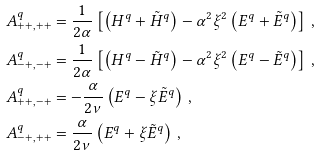<formula> <loc_0><loc_0><loc_500><loc_500>A _ { + + , + + } ^ { q } & = \frac { 1 } { 2 \alpha } \left [ \left ( H ^ { q } + \tilde { H } ^ { q } \right ) - \alpha ^ { 2 } \xi ^ { 2 } \left ( E ^ { q } + \tilde { E } ^ { q } \right ) \right ] \, , \\ A _ { - + , - + } ^ { q } & = \frac { 1 } { 2 \alpha } \left [ \left ( H ^ { q } - \tilde { H } ^ { q } \right ) - \alpha ^ { 2 } \xi ^ { 2 } \left ( E ^ { q } - \tilde { E } ^ { q } \right ) \right ] \, , \\ A _ { + + , - + } ^ { q } & = - \frac { \alpha } { 2 \nu } \left ( E ^ { q } - \xi \tilde { E } ^ { q } \right ) \, , \\ A _ { - + , + + } ^ { q } & = \frac { \alpha } { 2 \nu } \left ( E ^ { q } + \xi \tilde { E } ^ { q } \right ) \, ,</formula> 